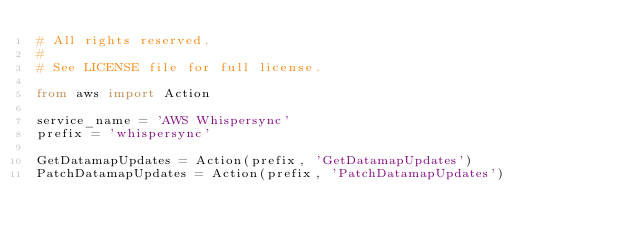Convert code to text. <code><loc_0><loc_0><loc_500><loc_500><_Python_># All rights reserved.
#
# See LICENSE file for full license.

from aws import Action

service_name = 'AWS Whispersync'
prefix = 'whispersync'

GetDatamapUpdates = Action(prefix, 'GetDatamapUpdates')
PatchDatamapUpdates = Action(prefix, 'PatchDatamapUpdates')
</code> 